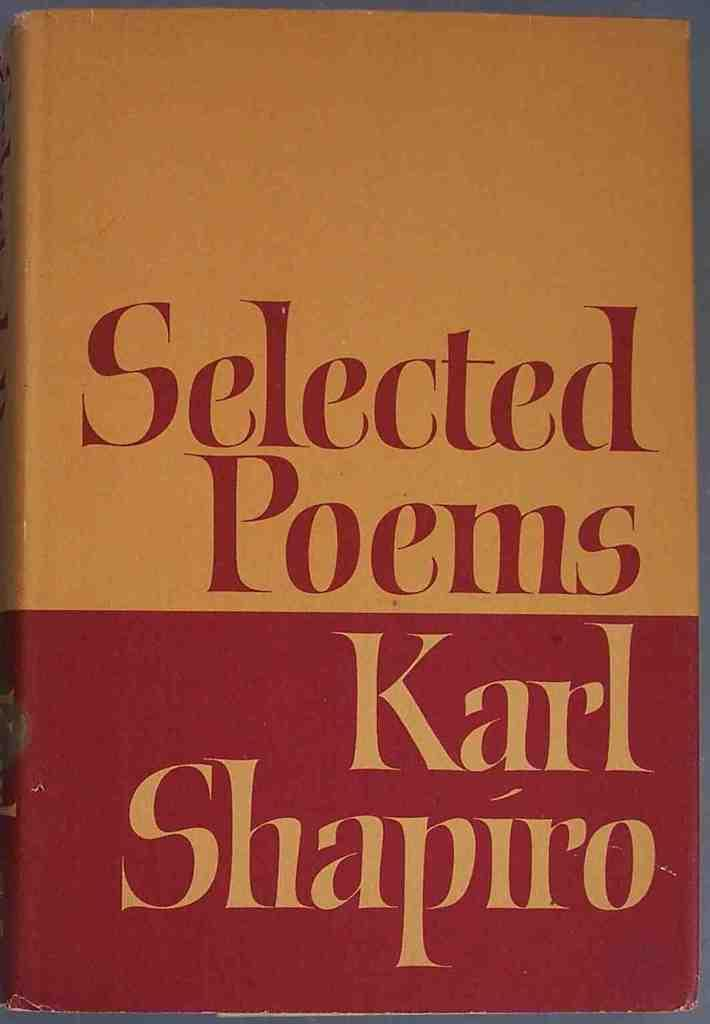<image>
Summarize the visual content of the image. A book of Selected Poems by Carl Shapiro. 